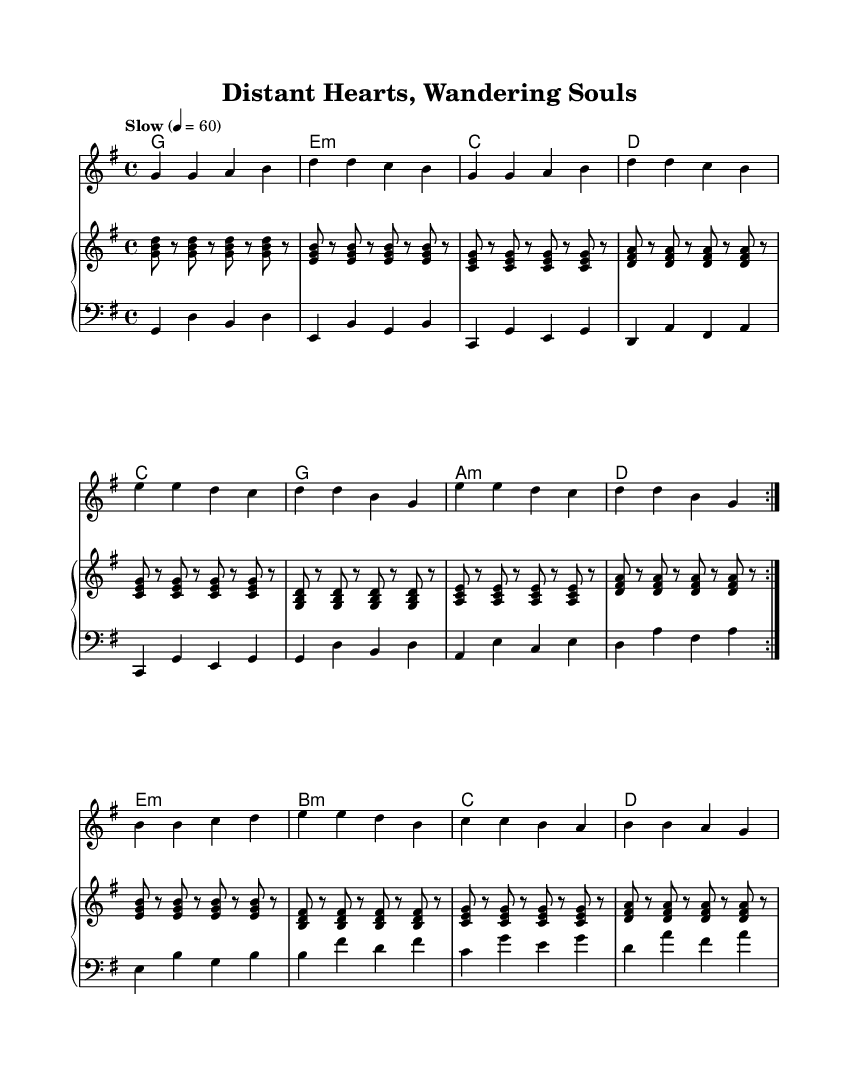What is the key signature of this music? The key signature is G major, which has one sharp (F#). This can be determined by finding the key signature at the beginning of the sheet music above the staff.
Answer: G major What is the time signature of this music? The time signature is 4/4, which indicates 4 beats per measure and the quarter note gets one beat. This is shown at the beginning of the score next to the clef.
Answer: 4/4 What is the tempo marking of this piece? The tempo marking indicates a slow pace, specifically "Slow" with a metronome marking of 60 beats per minute. This is visible in the tempo indication on the score.
Answer: Slow How many measures are there in the melody section? The melody section contains 16 measures, which can be counted by looking at the bar lines dividing the staff.
Answer: 16 What are the chord progressions used throughout the piece? The chord progressions follow a repeating pattern of G, E minor, C, and D, indicating a common structure in R&B ballads. This can be identified from the chord names written above the measure lines.
Answer: G, E minor, C, D What is the primary emotional theme of this ballad? The primary emotional theme revolves around longing and separation associated with long-distance love, as conveyed through the lyrics and musical phrases typical in soul and R&B styles. This is inferred from the context provided in the title and nature of the melody.
Answer: Longing Which instruments are involved in performing this composition? The composition features a piano, with separate parts for the right and left hands, along with chord names indicating harmony. This is clear from the structure of the score, which includes a PianoStaff.
Answer: Piano 